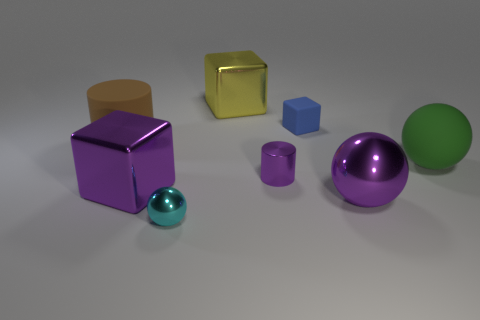Add 2 tiny metal things. How many objects exist? 10 Subtract all small blue cubes. How many cubes are left? 2 Subtract 1 blocks. How many blocks are left? 2 Subtract all purple cubes. How many cubes are left? 2 Subtract all cubes. How many objects are left? 5 Subtract all yellow cylinders. How many yellow spheres are left? 0 Subtract all green matte things. Subtract all big green matte balls. How many objects are left? 6 Add 5 tiny purple metal things. How many tiny purple metal things are left? 6 Add 3 big purple blocks. How many big purple blocks exist? 4 Subtract 1 purple cylinders. How many objects are left? 7 